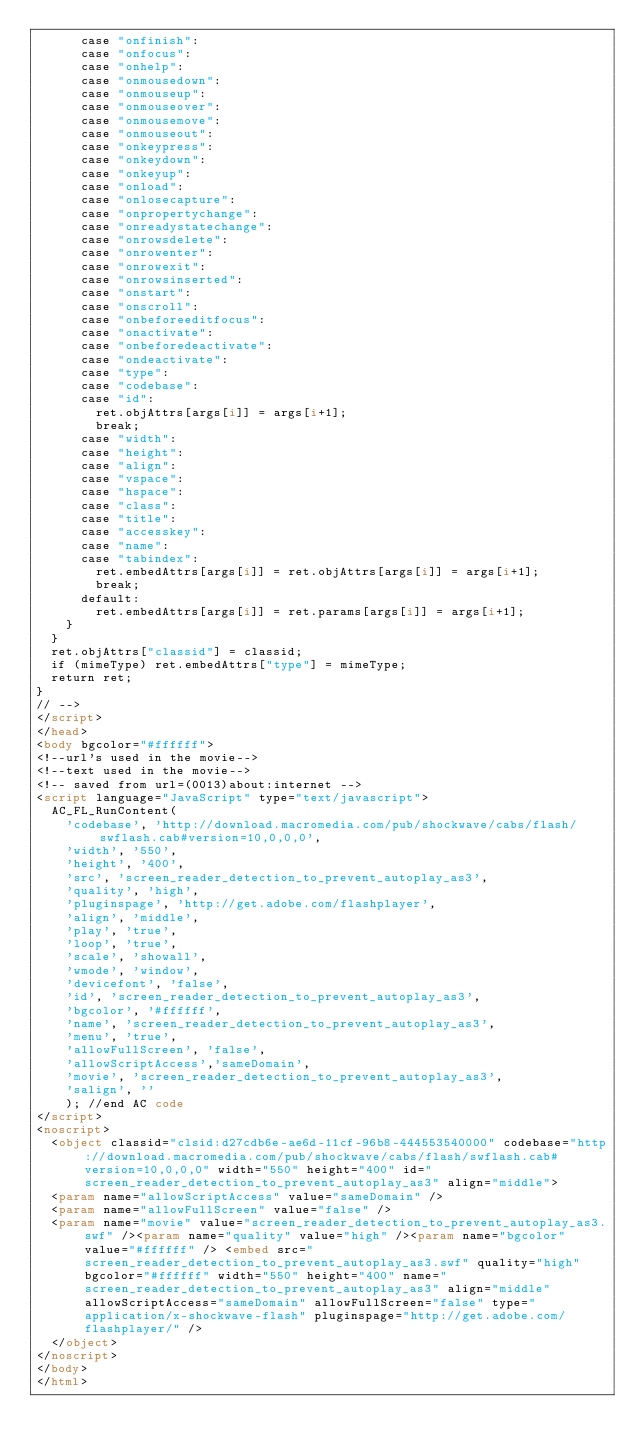Convert code to text. <code><loc_0><loc_0><loc_500><loc_500><_HTML_>      case "onfinish":
      case "onfocus":
      case "onhelp":
      case "onmousedown":
      case "onmouseup":
      case "onmouseover":
      case "onmousemove":
      case "onmouseout":
      case "onkeypress":
      case "onkeydown":
      case "onkeyup":
      case "onload":
      case "onlosecapture":
      case "onpropertychange":
      case "onreadystatechange":
      case "onrowsdelete":
      case "onrowenter":
      case "onrowexit":
      case "onrowsinserted":
      case "onstart":
      case "onscroll":
      case "onbeforeeditfocus":
      case "onactivate":
      case "onbeforedeactivate":
      case "ondeactivate":
      case "type":
      case "codebase":
      case "id":
        ret.objAttrs[args[i]] = args[i+1];
        break;
      case "width":
      case "height":
      case "align":
      case "vspace": 
      case "hspace":
      case "class":
      case "title":
      case "accesskey":
      case "name":
      case "tabindex":
        ret.embedAttrs[args[i]] = ret.objAttrs[args[i]] = args[i+1];
        break;
      default:
        ret.embedAttrs[args[i]] = ret.params[args[i]] = args[i+1];
    }
  }
  ret.objAttrs["classid"] = classid;
  if (mimeType) ret.embedAttrs["type"] = mimeType;
  return ret;
}
// -->
</script>
</head>
<body bgcolor="#ffffff">
<!--url's used in the movie-->
<!--text used in the movie-->
<!-- saved from url=(0013)about:internet -->
<script language="JavaScript" type="text/javascript">
	AC_FL_RunContent(
		'codebase', 'http://download.macromedia.com/pub/shockwave/cabs/flash/swflash.cab#version=10,0,0,0',
		'width', '550',
		'height', '400',
		'src', 'screen_reader_detection_to_prevent_autoplay_as3',
		'quality', 'high',
		'pluginspage', 'http://get.adobe.com/flashplayer',
		'align', 'middle',
		'play', 'true',
		'loop', 'true',
		'scale', 'showall',
		'wmode', 'window',
		'devicefont', 'false',
		'id', 'screen_reader_detection_to_prevent_autoplay_as3',
		'bgcolor', '#ffffff',
		'name', 'screen_reader_detection_to_prevent_autoplay_as3',
		'menu', 'true',
		'allowFullScreen', 'false',
		'allowScriptAccess','sameDomain',
		'movie', 'screen_reader_detection_to_prevent_autoplay_as3',
		'salign', ''
		); //end AC code
</script>
<noscript>
	<object classid="clsid:d27cdb6e-ae6d-11cf-96b8-444553540000" codebase="http://download.macromedia.com/pub/shockwave/cabs/flash/swflash.cab#version=10,0,0,0" width="550" height="400" id="screen_reader_detection_to_prevent_autoplay_as3" align="middle">
	<param name="allowScriptAccess" value="sameDomain" />
	<param name="allowFullScreen" value="false" />
	<param name="movie" value="screen_reader_detection_to_prevent_autoplay_as3.swf" /><param name="quality" value="high" /><param name="bgcolor" value="#ffffff" />	<embed src="screen_reader_detection_to_prevent_autoplay_as3.swf" quality="high" bgcolor="#ffffff" width="550" height="400" name="screen_reader_detection_to_prevent_autoplay_as3" align="middle" allowScriptAccess="sameDomain" allowFullScreen="false" type="application/x-shockwave-flash" pluginspage="http://get.adobe.com/flashplayer/" />
	</object>
</noscript>
</body>
</html>
</code> 